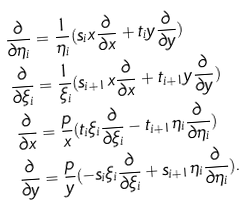<formula> <loc_0><loc_0><loc_500><loc_500>\frac { \partial } { \partial \eta _ { i } } & = \frac { 1 } { \eta _ { i } } ( s _ { i } x \frac { \partial } { \partial x } + t _ { i } y \frac { \partial } { \partial y } ) \\ \frac { \partial } { \partial \xi _ { i } } & = \frac { 1 } { \xi _ { i } } ( s _ { i + 1 } x \frac { \partial } { \partial x } + t _ { i + 1 } y \frac { \partial } { \partial y } ) \\ \frac { \partial } { \partial x } & = \frac { p } { x } ( t _ { i } \xi _ { i } \frac { \partial } { \partial \xi _ { i } } - t _ { i + 1 } \eta _ { i } \frac { \partial } { \partial \eta _ { i } } ) \\ \frac { \partial } { \partial y } & = \frac { p } { y } ( - s _ { i } \xi _ { i } \frac { \partial } { \partial \xi _ { i } } + s _ { i + 1 } \eta _ { i } \frac { \partial } { \partial \eta _ { i } } ) .</formula> 